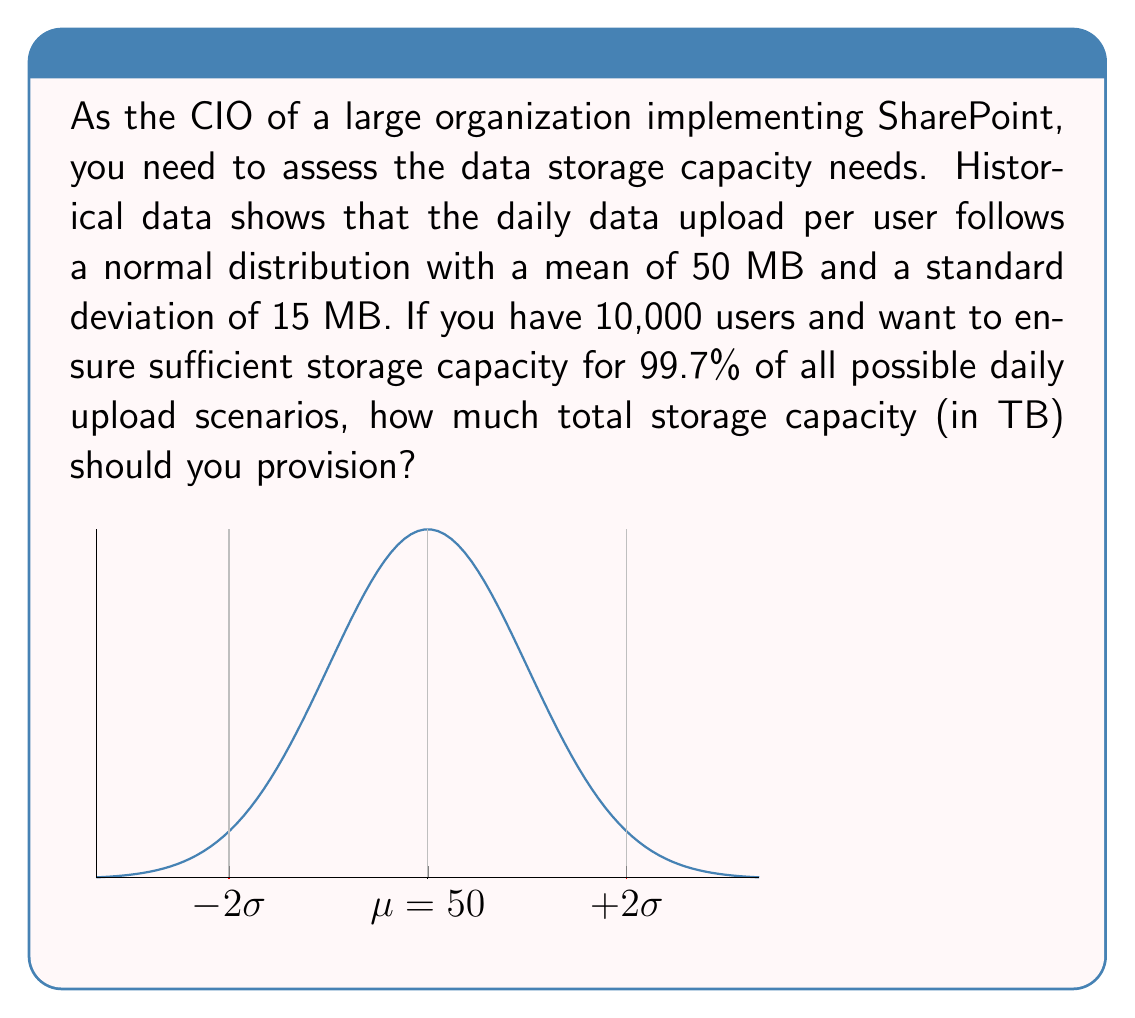Help me with this question. Let's approach this step-by-step:

1) The daily data upload per user follows a normal distribution:
   $X \sim N(\mu = 50, \sigma = 15)$

2) We want to cover 99.7% of all scenarios, which corresponds to $\mu \pm 3\sigma$ in a normal distribution.

3) Calculate the upper bound of the daily upload per user:
   $\text{Upper bound} = \mu + 3\sigma = 50 + 3(15) = 95$ MB

4) For 10,000 users, the total daily upload capacity needed:
   $\text{Total capacity} = 10,000 \times 95 = 950,000$ MB

5) Convert MB to TB:
   $950,000 \text{ MB} = 950,000 \div 1,000,000 = 0.95$ TB

6) Round up to ensure sufficient capacity:
   $0.95 \text{ TB} \approx 1 \text{ TB}$

Therefore, to cover 99.7% of all possible daily upload scenarios for 10,000 users, you should provision 1 TB of storage capacity.
Answer: 1 TB 